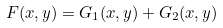Convert formula to latex. <formula><loc_0><loc_0><loc_500><loc_500>F ( x , y ) = G _ { 1 } ( x , y ) + G _ { 2 } ( x , y ) \\</formula> 